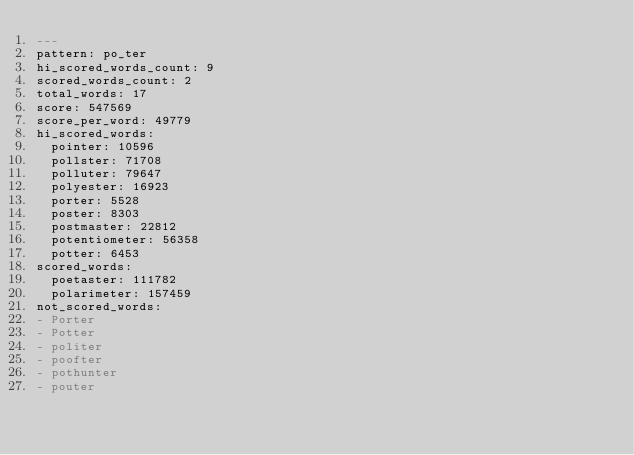Convert code to text. <code><loc_0><loc_0><loc_500><loc_500><_YAML_>---
pattern: po_ter
hi_scored_words_count: 9
scored_words_count: 2
total_words: 17
score: 547569
score_per_word: 49779
hi_scored_words:
  pointer: 10596
  pollster: 71708
  polluter: 79647
  polyester: 16923
  porter: 5528
  poster: 8303
  postmaster: 22812
  potentiometer: 56358
  potter: 6453
scored_words:
  poetaster: 111782
  polarimeter: 157459
not_scored_words:
- Porter
- Potter
- politer
- poofter
- pothunter
- pouter
</code> 